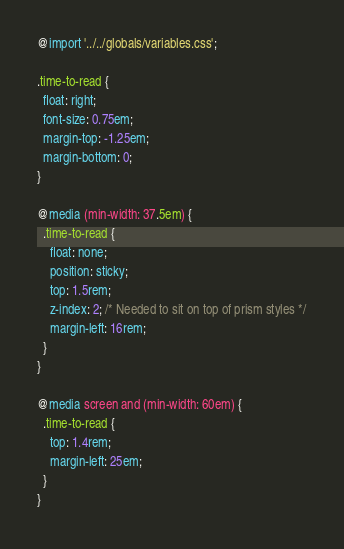<code> <loc_0><loc_0><loc_500><loc_500><_CSS_>@import '../../globals/variables.css';

.time-to-read {
  float: right;
  font-size: 0.75em;
  margin-top: -1.25em;
  margin-bottom: 0;
}

@media (min-width: 37.5em) {
  .time-to-read {
    float: none;
    position: sticky;
    top: 1.5rem;
    z-index: 2; /* Needed to sit on top of prism styles */
    margin-left: 16rem;
  }
}

@media screen and (min-width: 60em) {
  .time-to-read {
    top: 1.4rem;
    margin-left: 25em;
  }
}</code> 